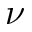<formula> <loc_0><loc_0><loc_500><loc_500>\nu</formula> 